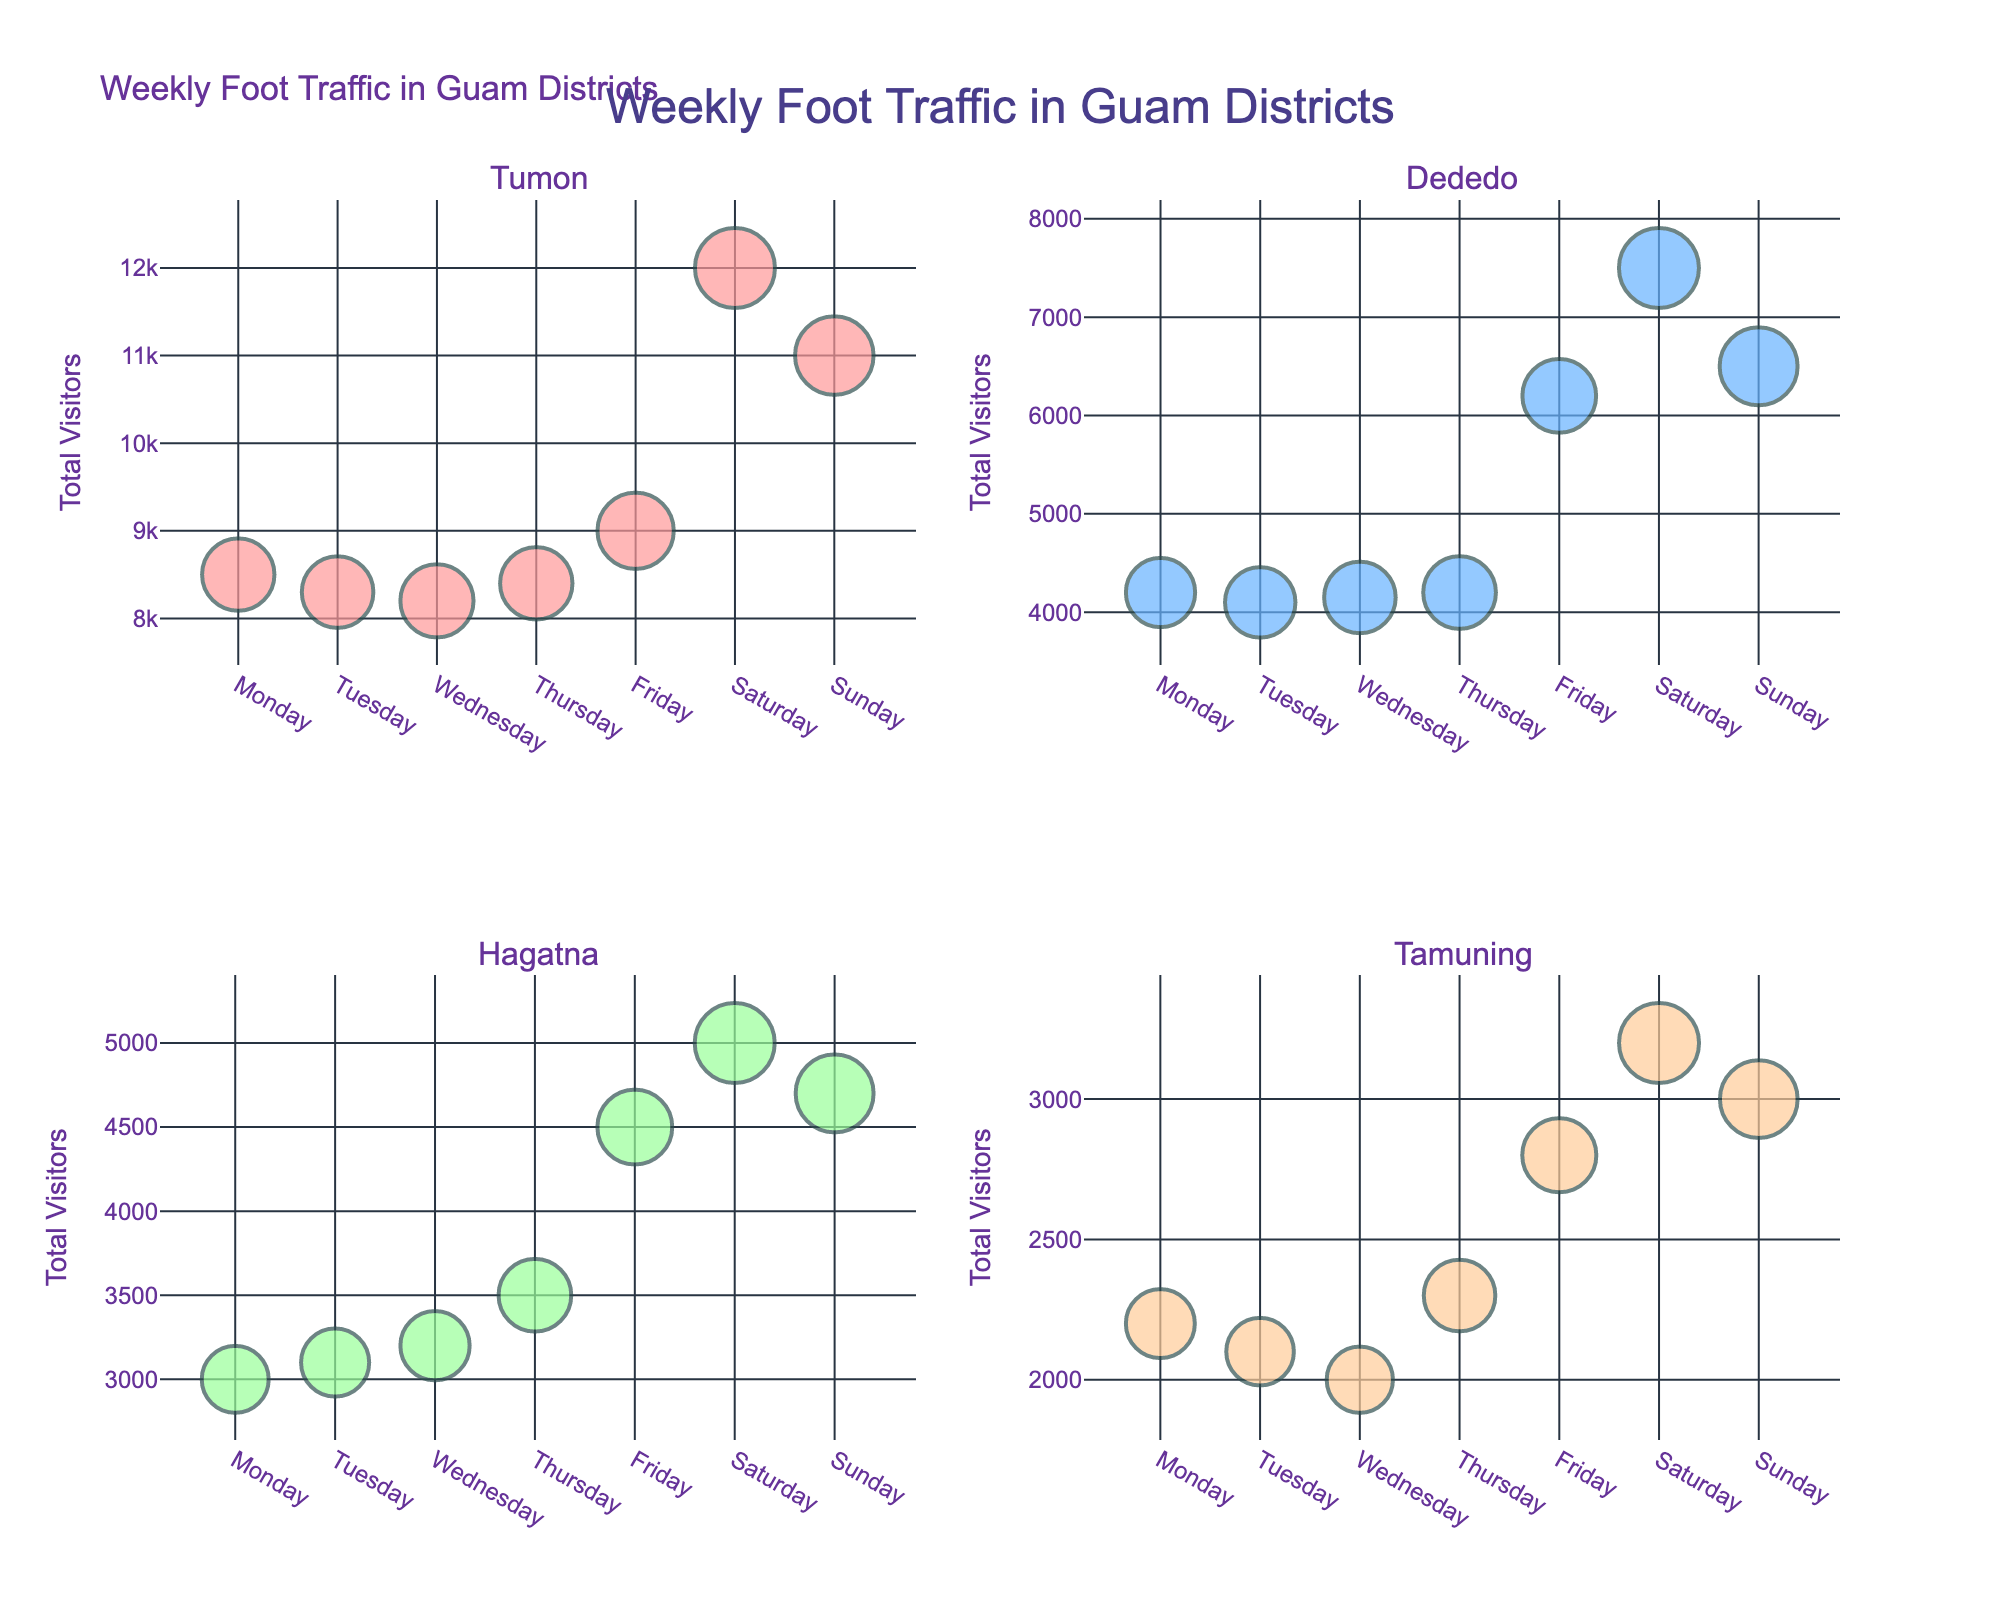What's the title of the figure? The title of the figure is displayed prominently at the top-center of the plot. It reads "Weekly Foot Traffic in Guam Districts."
Answer: Weekly Foot Traffic in Guam Districts Which district has the highest total visitors on Saturday? By observing the size and position of the bubbles for Saturday, Tumon's Micronesia Mall stands out clearly with the largest bubble, indicating the highest foot traffic.
Answer: Tumon In which district and location do visitors spend the most average time on Sundays? By looking at the bubbles for Sunday, the largest one in terms of size corresponds to Tumon's Micronesia Mall, indicating the longest average stay.
Answer: Tumon, Micronesia Mall Compare the total visitors between Tumon and Dededo on Fridays. Which has more visitors? By comparing the heights of the bubbles under "Friday" for both districts, it's apparent that Tumon has a taller bubble compared to Dededo, indicating higher visitor counts.
Answer: Tumon How does the average stay on Wednesdays in Dededo compare to that in Hagatna? The bubble sizes on Wednesday for Dededo are slightly larger than those for Hagatna, indicating a longer average stay in Dededo.
Answer: Dededo has a longer average stay What is the total visitor difference between Tumon and Hagatna on Saturday? Tumon has 12000 visitors and Hagatna has 5000 on Saturday. The difference is calculated as 12000 - 5000.
Answer: 7000 Which location has the least total visitors on Tuesdays? By looking at the smallest bubble for Tuesday, Tamuning's Paseo de Susana Park has the least total visitors.
Answer: Tamuning, Paseo de Susana Park What's the general trend of foot traffic in Tumon from Monday to Sunday? Observing the series of bubbles from Monday to Sunday in Tumon, the trend shows an increase in visitor count, peaking on Saturday and slightly decreasing on Sunday.
Answer: Increasing, peaking on Saturday Which location has more total visitors on weekdays than weekends? By summing up weekday and weekend visitor counts for each location, Dededo's Guam Premier Outlets have more visitors on weekdays (16550) than weekends (14000).
Answer: Dededo, Guam Premier Outlets What day has the highest total traffic in all locations combined? Evaluating the height and size of all bubbles across days, Saturday consistently has the highest total traffic in each location.
Answer: Saturday 